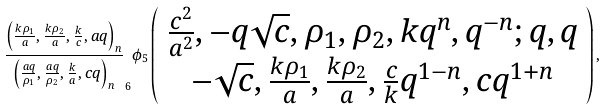<formula> <loc_0><loc_0><loc_500><loc_500>\frac { \left ( \frac { k \rho _ { 1 } } { a } , \frac { k \rho _ { 2 } } { a } , \frac { k } { c } , a q \right ) _ { n } } { \left ( \frac { a q } { \rho _ { 1 } } , \frac { a q } { \rho _ { 2 } } , \frac { k } { a } , c q \right ) _ { n } } _ { 6 } \phi _ { 5 } \left ( \begin{array} { c } \frac { c ^ { 2 } } { a ^ { 2 } } , - q \sqrt { c } , \rho _ { 1 } , \rho _ { 2 } , k q ^ { n } , q ^ { - n } ; q , q \\ - \sqrt { c } , \frac { k \rho _ { 1 } } { a } , \frac { k \rho _ { 2 } } { a } , \frac { c } { k } q ^ { 1 - n } , c q ^ { 1 + n } \end{array} \right ) ,</formula> 